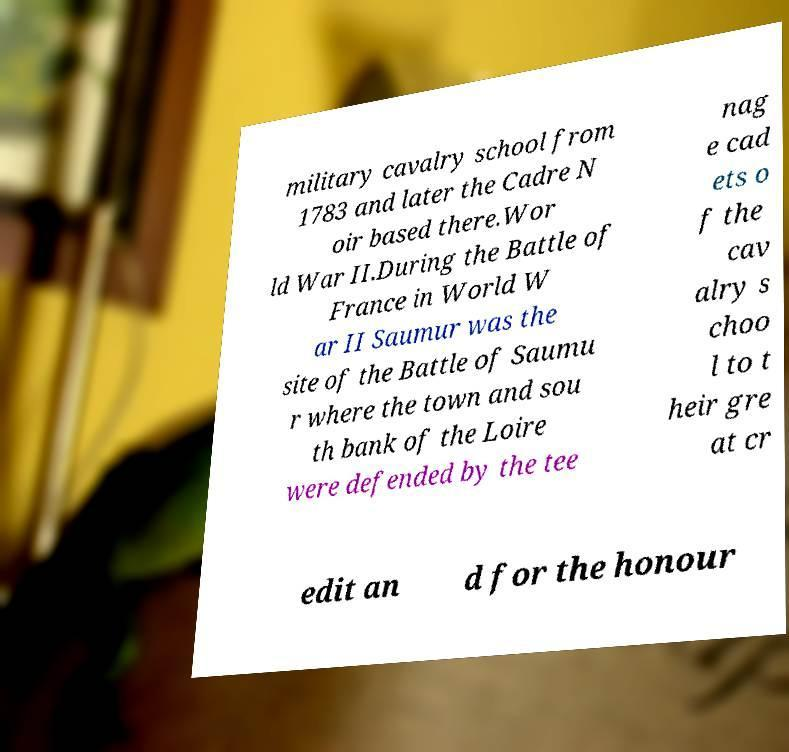Could you extract and type out the text from this image? military cavalry school from 1783 and later the Cadre N oir based there.Wor ld War II.During the Battle of France in World W ar II Saumur was the site of the Battle of Saumu r where the town and sou th bank of the Loire were defended by the tee nag e cad ets o f the cav alry s choo l to t heir gre at cr edit an d for the honour 